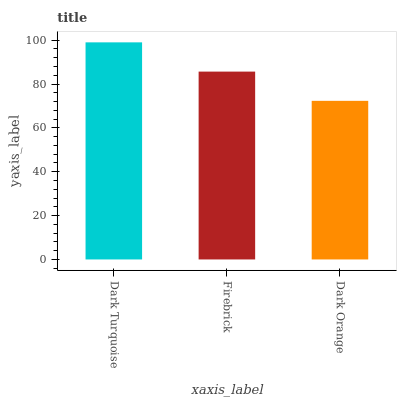Is Firebrick the minimum?
Answer yes or no. No. Is Firebrick the maximum?
Answer yes or no. No. Is Dark Turquoise greater than Firebrick?
Answer yes or no. Yes. Is Firebrick less than Dark Turquoise?
Answer yes or no. Yes. Is Firebrick greater than Dark Turquoise?
Answer yes or no. No. Is Dark Turquoise less than Firebrick?
Answer yes or no. No. Is Firebrick the high median?
Answer yes or no. Yes. Is Firebrick the low median?
Answer yes or no. Yes. Is Dark Turquoise the high median?
Answer yes or no. No. Is Dark Orange the low median?
Answer yes or no. No. 